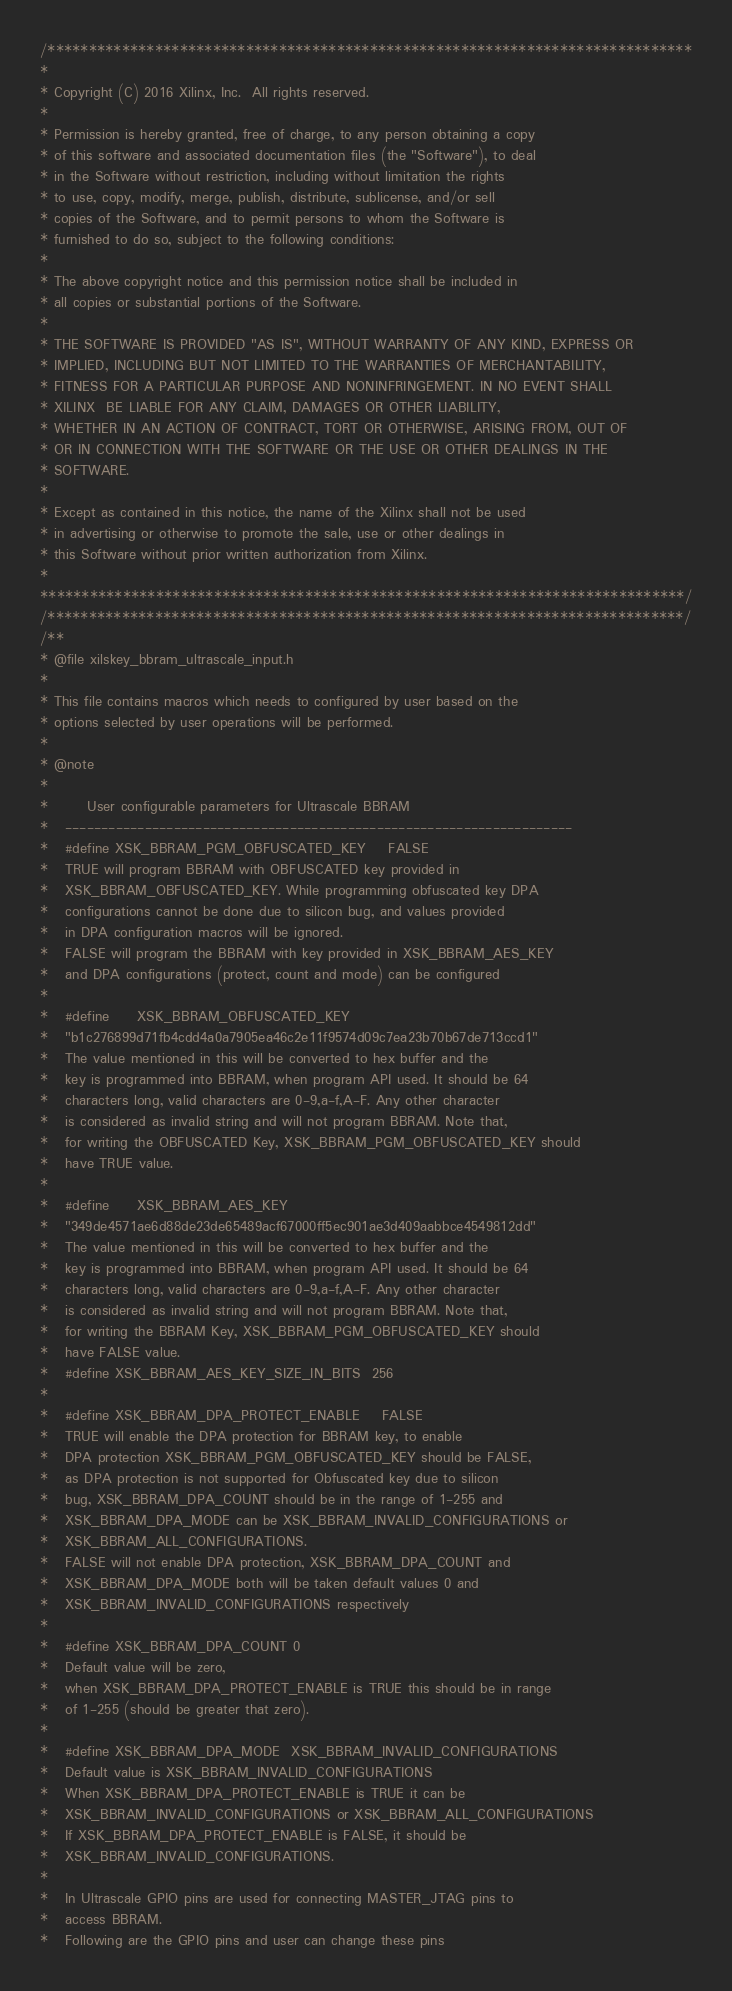<code> <loc_0><loc_0><loc_500><loc_500><_C_>/******************************************************************************
*
* Copyright (C) 2016 Xilinx, Inc.  All rights reserved.
*
* Permission is hereby granted, free of charge, to any person obtaining a copy
* of this software and associated documentation files (the "Software"), to deal
* in the Software without restriction, including without limitation the rights
* to use, copy, modify, merge, publish, distribute, sublicense, and/or sell
* copies of the Software, and to permit persons to whom the Software is
* furnished to do so, subject to the following conditions:
*
* The above copyright notice and this permission notice shall be included in
* all copies or substantial portions of the Software.
*
* THE SOFTWARE IS PROVIDED "AS IS", WITHOUT WARRANTY OF ANY KIND, EXPRESS OR
* IMPLIED, INCLUDING BUT NOT LIMITED TO THE WARRANTIES OF MERCHANTABILITY,
* FITNESS FOR A PARTICULAR PURPOSE AND NONINFRINGEMENT. IN NO EVENT SHALL
* XILINX  BE LIABLE FOR ANY CLAIM, DAMAGES OR OTHER LIABILITY,
* WHETHER IN AN ACTION OF CONTRACT, TORT OR OTHERWISE, ARISING FROM, OUT OF
* OR IN CONNECTION WITH THE SOFTWARE OR THE USE OR OTHER DEALINGS IN THE
* SOFTWARE.
*
* Except as contained in this notice, the name of the Xilinx shall not be used
* in advertising or otherwise to promote the sale, use or other dealings in
* this Software without prior written authorization from Xilinx.
*
******************************************************************************/
/*****************************************************************************/
/**
* @file xilskey_bbram_ultrascale_input.h
*
* This file contains macros which needs to configured by user based on the
* options selected by user operations will be performed.
*
* @note
*
*  		User configurable parameters for Ultrascale BBRAM
*  	----------------------------------------------------------------------
*	#define XSK_BBRAM_PGM_OBFUSCATED_KEY	FALSE
*	TRUE will program BBRAM with OBFUSCATED key provided in
*	XSK_BBRAM_OBFUSCATED_KEY. While programming obfuscated key DPA
*	configurations cannot be done due to silicon bug, and values provided
*	in DPA configuration macros will be ignored.
*	FALSE will program the BBRAM with key provided in XSK_BBRAM_AES_KEY
*	and DPA configurations (protect, count and mode) can be configured
*
*	#define		XSK_BBRAM_OBFUSCATED_KEY
*	"b1c276899d71fb4cdd4a0a7905ea46c2e11f9574d09c7ea23b70b67de713ccd1"
*	The value mentioned in this will be converted to hex buffer and the
*	key is programmed into BBRAM, when program API used. It should be 64
*	characters long, valid characters are 0-9,a-f,A-F. Any other character
*	is considered as invalid string and will not program BBRAM. Note that,
*	for writing the OBFUSCATED Key, XSK_BBRAM_PGM_OBFUSCATED_KEY should
*	have TRUE value.
*
* 	#define 	XSK_BBRAM_AES_KEY
*	"349de4571ae6d88de23de65489acf67000ff5ec901ae3d409aabbce4549812dd"
*	The value mentioned in this will be converted to hex buffer and the
*	key is programmed into BBRAM, when program API used. It should be 64
*	characters long, valid characters are 0-9,a-f,A-F. Any other character
*	is considered as invalid string and will not program BBRAM. Note that,
*	for writing the BBRAM Key, XSK_BBRAM_PGM_OBFUSCATED_KEY should
*	have FALSE value.
* 	#define	XSK_BBRAM_AES_KEY_SIZE_IN_BITS	256
*
*	#define XSK_BBRAM_DPA_PROTECT_ENABLE	FALSE
*	TRUE will enable the DPA protection for BBRAM key, to enable
*	DPA protection XSK_BBRAM_PGM_OBFUSCATED_KEY should be FALSE,
*	as DPA protection is not supported for Obfuscated key due to silicon
*	bug, XSK_BBRAM_DPA_COUNT should be in the range of 1-255 and
*	XSK_BBRAM_DPA_MODE can be XSK_BBRAM_INVALID_CONFIGURATIONS or
*	XSK_BBRAM_ALL_CONFIGURATIONS.
*	FALSE will not enable DPA protection, XSK_BBRAM_DPA_COUNT and
*	XSK_BBRAM_DPA_MODE both will be taken default values 0 and
*	XSK_BBRAM_INVALID_CONFIGURATIONS respectively
*
*	#define XSK_BBRAM_DPA_COUNT	0
*	Default value will be zero,
*	when XSK_BBRAM_DPA_PROTECT_ENABLE is TRUE this should be in range
*	of 1-255 (should be greater that zero).
*
*	#define XSK_BBRAM_DPA_MODE	XSK_BBRAM_INVALID_CONFIGURATIONS
*	Default value is XSK_BBRAM_INVALID_CONFIGURATIONS
*	When XSK_BBRAM_DPA_PROTECT_ENABLE is TRUE it can be
*	XSK_BBRAM_INVALID_CONFIGURATIONS or XSK_BBRAM_ALL_CONFIGURATIONS
*	If XSK_BBRAM_DPA_PROTECT_ENABLE is FALSE, it should be
*	XSK_BBRAM_INVALID_CONFIGURATIONS.
*
*	In Ultrascale GPIO pins are used for connecting MASTER_JTAG pins to
*	access BBRAM.
*	Following are the GPIO pins and user can change these pins</code> 